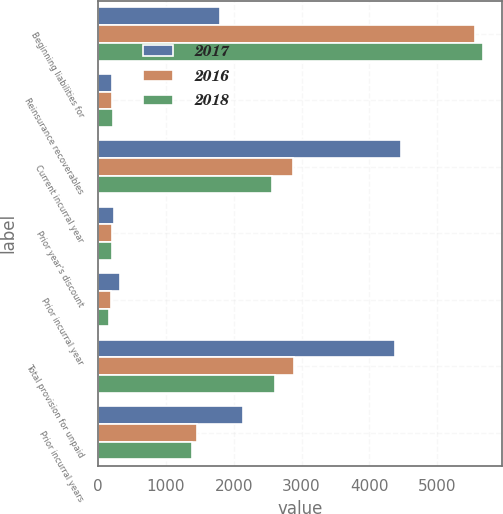Convert chart to OTSL. <chart><loc_0><loc_0><loc_500><loc_500><stacked_bar_chart><ecel><fcel>Beginning liabilities for<fcel>Reinsurance recoverables<fcel>Current incurral year<fcel>Prior year's discount<fcel>Prior incurral year<fcel>Total provision for unpaid<fcel>Prior incurral years<nl><fcel>2017<fcel>1793<fcel>209<fcel>4470<fcel>227<fcel>324<fcel>4373<fcel>2135<nl><fcel>2016<fcel>5564<fcel>208<fcel>2868<fcel>202<fcel>185<fcel>2885<fcel>1451<nl><fcel>2018<fcel>5671<fcel>218<fcel>2562<fcel>202<fcel>162<fcel>2602<fcel>1382<nl></chart> 